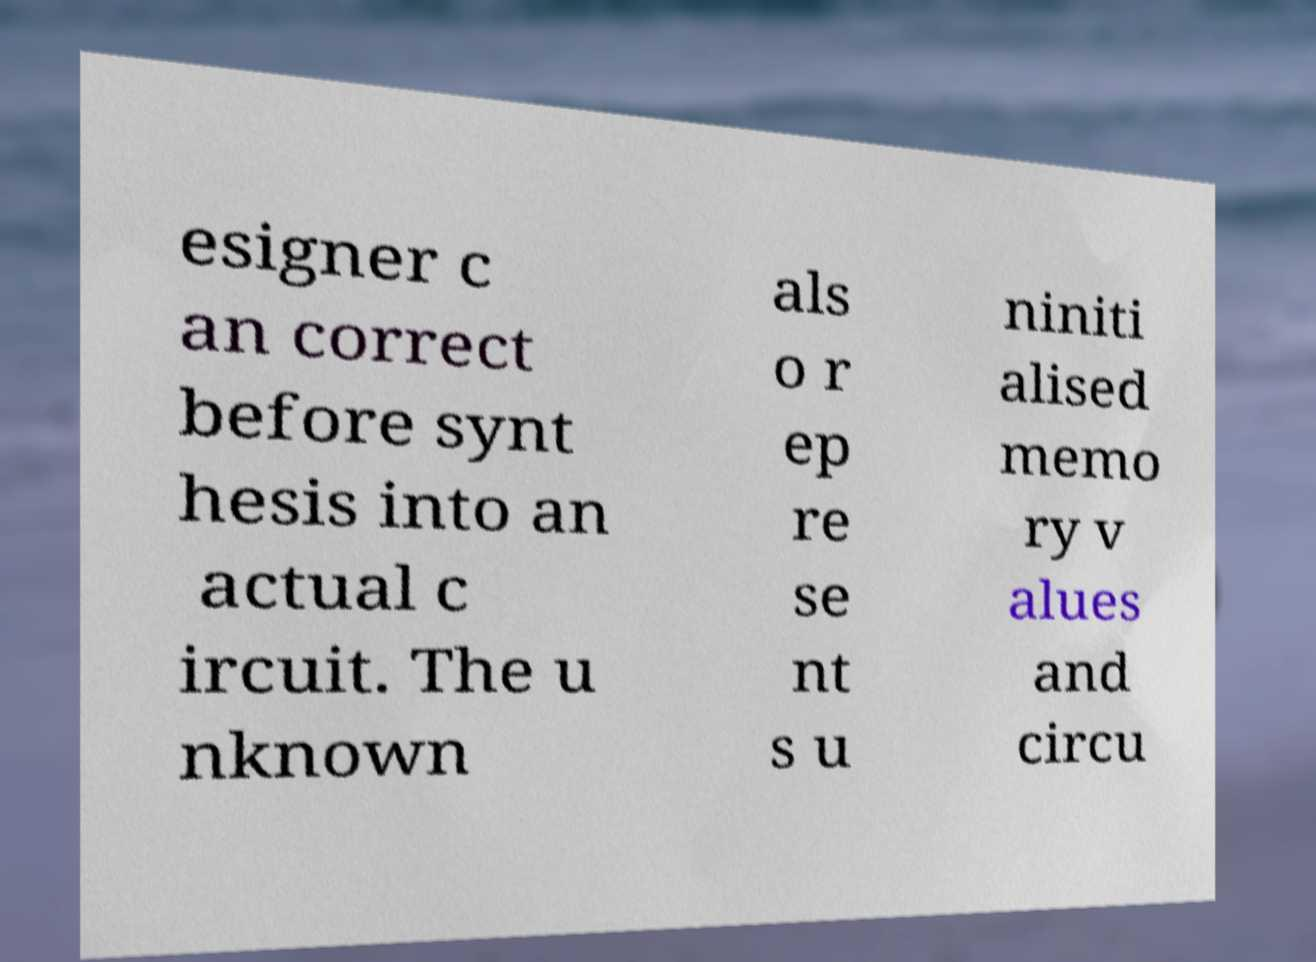Could you extract and type out the text from this image? esigner c an correct before synt hesis into an actual c ircuit. The u nknown als o r ep re se nt s u niniti alised memo ry v alues and circu 